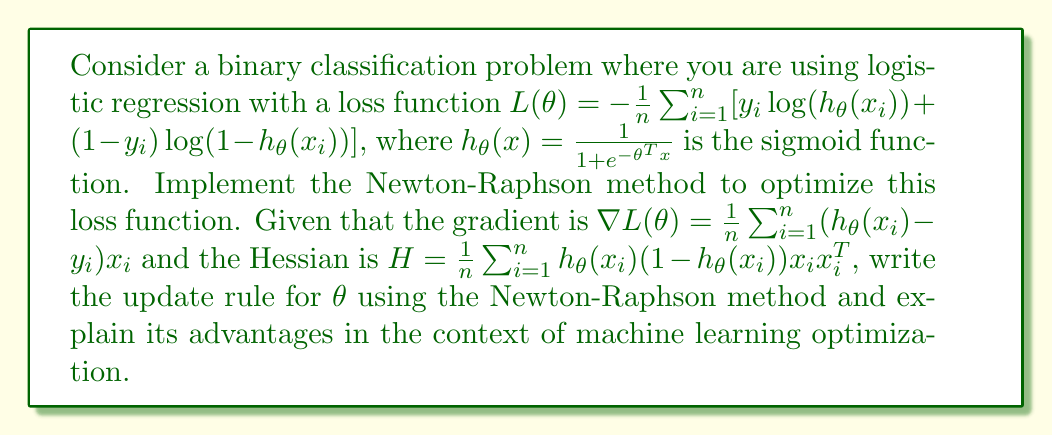Teach me how to tackle this problem. To implement the Newton-Raphson method for optimizing the logistic regression loss function, we follow these steps:

1. Recall the general form of the Newton-Raphson update rule:
   $$\theta_{t+1} = \theta_t - H^{-1}\nabla L(\theta_t)$$

2. Given the gradient and Hessian for our specific problem:
   $$\nabla L(\theta) = \frac{1}{n}\sum_{i=1}^n (h_\theta(x_i) - y_i)x_i$$
   $$H = \frac{1}{n}\sum_{i=1}^n h_\theta(x_i)(1-h_\theta(x_i))x_ix_i^T$$

3. Substituting these into the update rule:
   $$\theta_{t+1} = \theta_t - \left(\frac{1}{n}\sum_{i=1}^n h_\theta(x_i)(1-h_\theta(x_i))x_ix_i^T\right)^{-1} \left(\frac{1}{n}\sum_{i=1}^n (h_\theta(x_i) - y_i)x_i\right)$$

4. This update rule forms the core of the Newton-Raphson method for optimizing the logistic regression loss function.

Advantages in the context of machine learning optimization:

a) Faster convergence: Newton-Raphson typically converges in fewer iterations compared to first-order methods like gradient descent, especially near the optimum.

b) Scale-invariant: The method is invariant to the scaling of features, which can be beneficial in machine learning where feature scaling is often a concern.

c) Quadratic convergence: Near the optimum, Newton-Raphson exhibits quadratic convergence, making it very efficient in finding the exact minimum.

d) Implicit regularization: The Hessian provides curvature information, which can help in avoiding overfitting to some extent.

e) Adaptive step size: The step size is automatically adjusted based on the local curvature of the loss function, potentially leading to more stable optimization.

However, it's important to note that computing and inverting the Hessian can be computationally expensive for high-dimensional problems, which is a limitation of this method in large-scale machine learning applications.
Answer: $$\theta_{t+1} = \theta_t - \left(\frac{1}{n}\sum_{i=1}^n h_\theta(x_i)(1-h_\theta(x_i))x_ix_i^T\right)^{-1} \left(\frac{1}{n}\sum_{i=1}^n (h_\theta(x_i) - y_i)x_i\right)$$ 